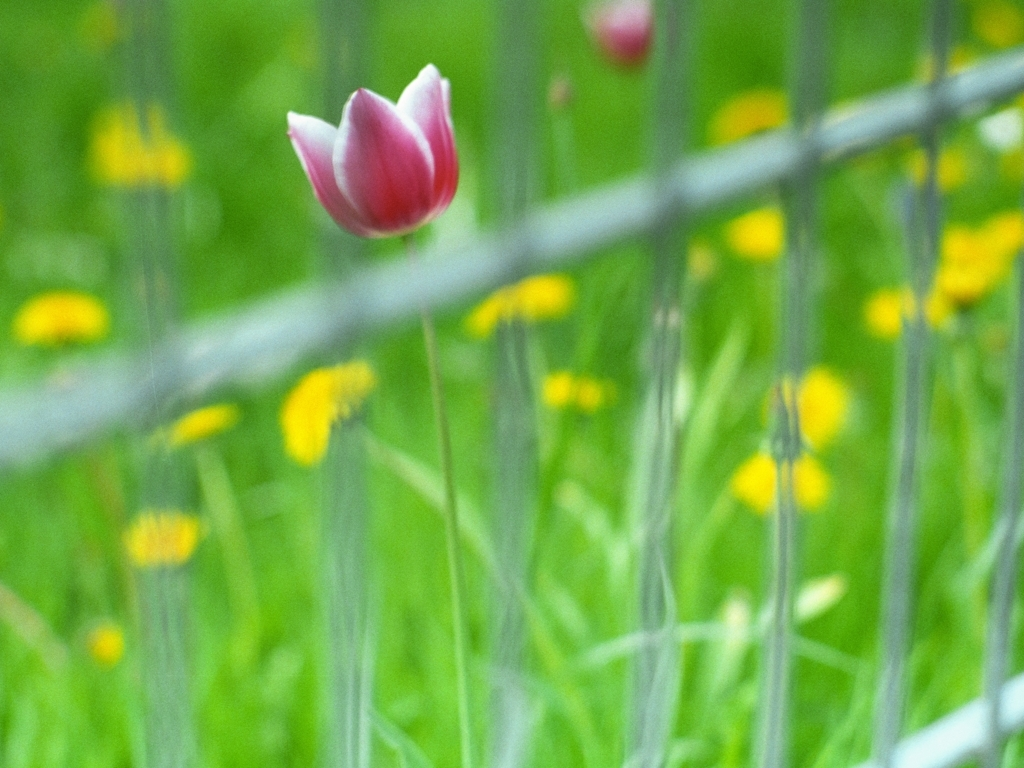Can you describe the atmosphere or feel of the image? The image conveys a serene, somewhat ethereal atmosphere. The softness of the blurring gives the scene a dreamy quality, while the solitary tulip standing against the blurred background suggests a sense of quiet solitude or a moment of peaceful focus amidst a chaotic environment. 